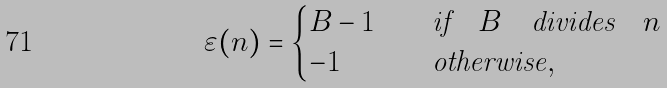<formula> <loc_0><loc_0><loc_500><loc_500>\varepsilon ( n ) = \begin{cases} B - 1 & \quad \text {if} \quad B \quad \text {divides} \quad n \\ - 1 & \quad \text {otherwise} , \end{cases}</formula> 